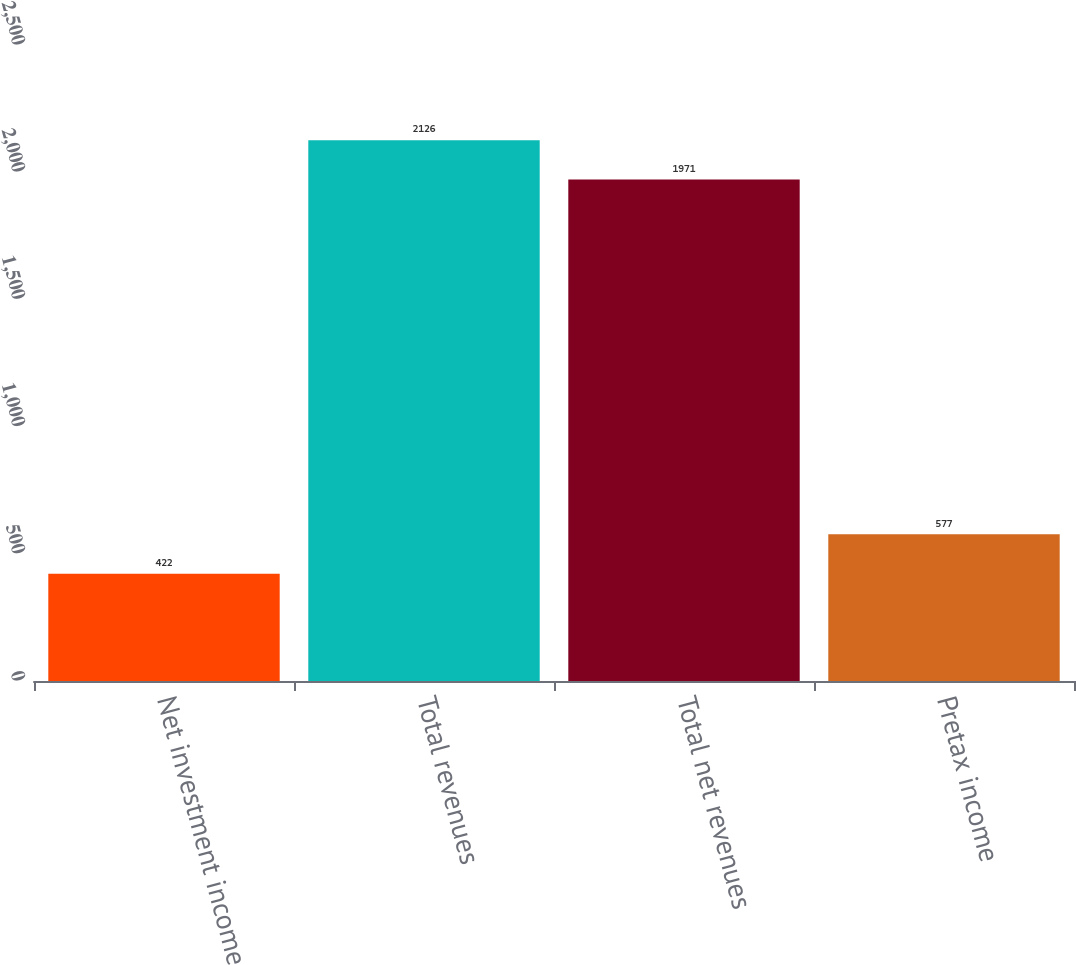<chart> <loc_0><loc_0><loc_500><loc_500><bar_chart><fcel>Net investment income<fcel>Total revenues<fcel>Total net revenues<fcel>Pretax income<nl><fcel>422<fcel>2126<fcel>1971<fcel>577<nl></chart> 